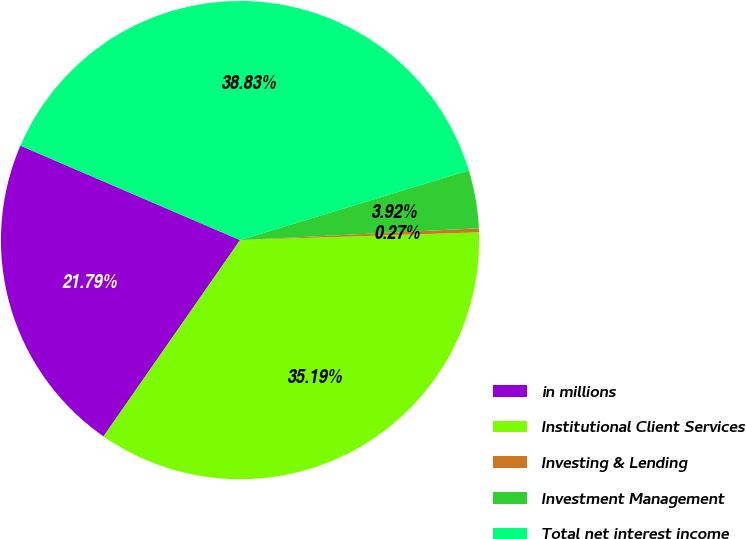<chart> <loc_0><loc_0><loc_500><loc_500><pie_chart><fcel>in millions<fcel>Institutional Client Services<fcel>Investing & Lending<fcel>Investment Management<fcel>Total net interest income<nl><fcel>21.79%<fcel>35.19%<fcel>0.27%<fcel>3.92%<fcel>38.83%<nl></chart> 